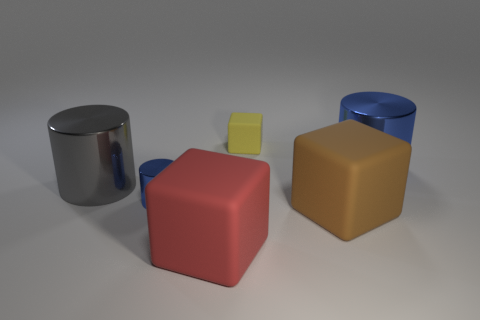Add 2 big cylinders. How many objects exist? 8 Add 1 large cylinders. How many large cylinders are left? 3 Add 5 large gray matte objects. How many large gray matte objects exist? 5 Subtract 0 gray cubes. How many objects are left? 6 Subtract all shiny things. Subtract all tiny matte things. How many objects are left? 2 